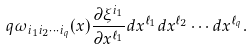Convert formula to latex. <formula><loc_0><loc_0><loc_500><loc_500>q \omega _ { i _ { 1 } i _ { 2 } \cdots i _ { q } } ( x ) \frac { \partial \xi ^ { i _ { 1 } } } { \partial x ^ { \ell _ { 1 } } } d x ^ { \ell _ { 1 } } d x ^ { \ell _ { 2 } } \cdots d x ^ { \ell _ { q } } .</formula> 